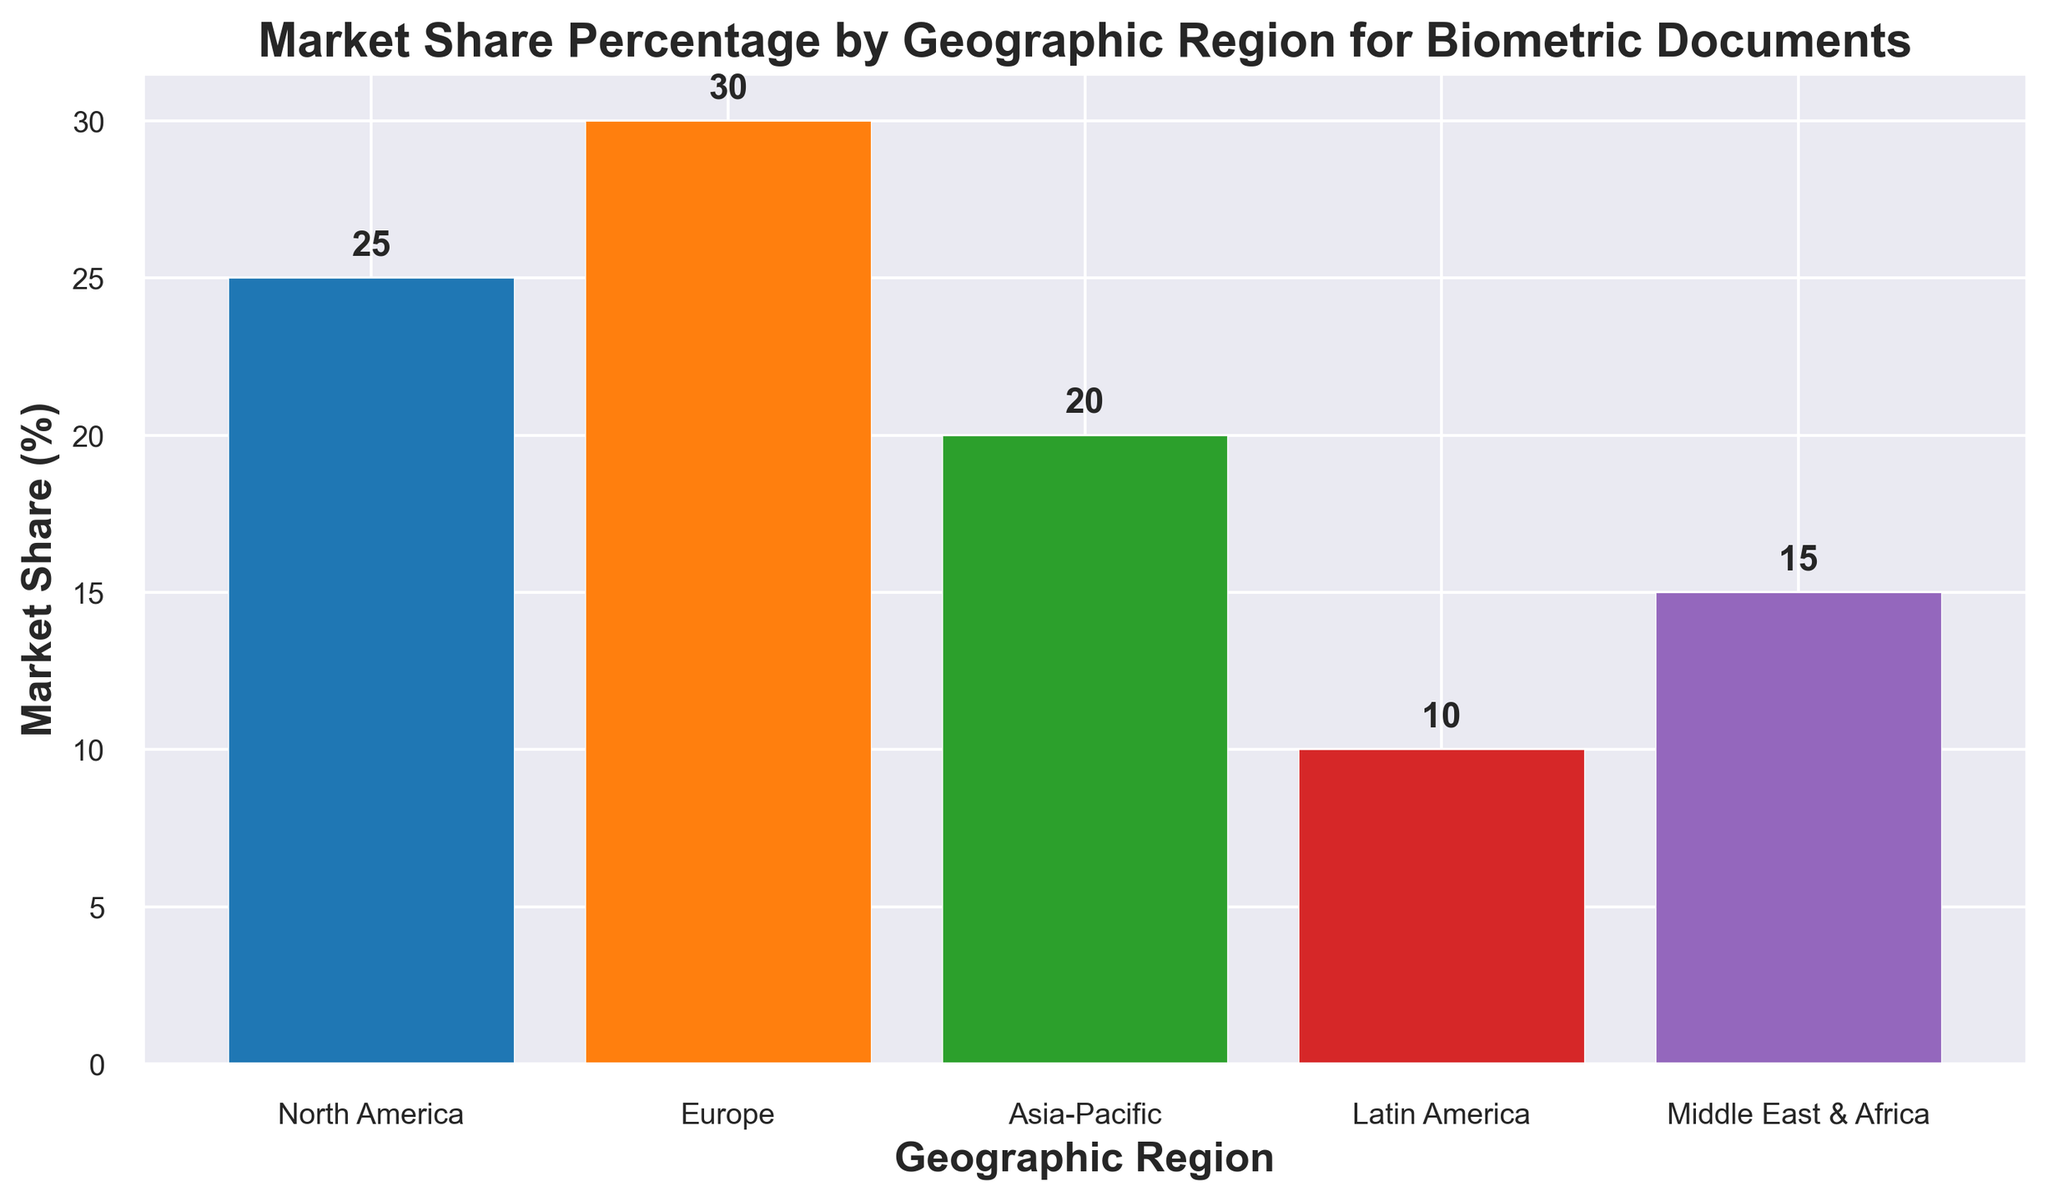Which geographic region has the highest market share for biometric documents? Look at the bar with the highest value, which is labeled "Europe" with a market share of 30%.
Answer: Europe Which regions have a market share of at least 20%? Identify the bars that show values of 20% or higher. North America (25%), Europe (30%), and Asia-Pacific (20%) meet this criterion.
Answer: North America, Europe, Asia-Pacific How does the market share of North America compare to Latin America? Refer to the bars representing North America and Latin America. North America has a market share of 25%, whereas Latin America has 10%. North America has a higher market share.
Answer: North America > Latin America What is the total market share of Asia-Pacific and Middle East & Africa combined? Sum the market share percentages of Asia-Pacific (20%) and Middle East & Africa (15%). The total is 20% + 15% = 35%.
Answer: 35% Which region has a market share closest to the median value among all regions? Rank the market share values to identify the median. The values are 10%, 15%, 20%, 25%, and 30%. The median value is 20%, which corresponds to Asia-Pacific.
Answer: Asia-Pacific Which regions have a lower market share than the Middle East & Africa? Identify bars with values less than 15%, which is the market share of the Middle East & Africa. Only Latin America (10%) has a lower value.
Answer: Latin America What is the difference in market share between Europe and Asia-Pacific? Subtract the market share of Asia-Pacific (20%) from Europe (30%). The difference is 30% - 20% = 10%.
Answer: 10% Order the regions from lowest to highest market share. Rank the regions based on their market share values: 10% (Latin America), 15% (Middle East & Africa), 20% (Asia-Pacific), 25% (North America), and 30% (Europe).
Answer: Latin America, Middle East & Africa, Asia-Pacific, North America, Europe If we combine the market shares of South America and Middle East & Africa, how does the resulting value compare to that of North America? Add the market shares of Latin America (10%) and Middle East & Africa (15%). The combined value is 10% + 15% = 25%, which is equal to North America's market share.
Answer: Equal to North America 